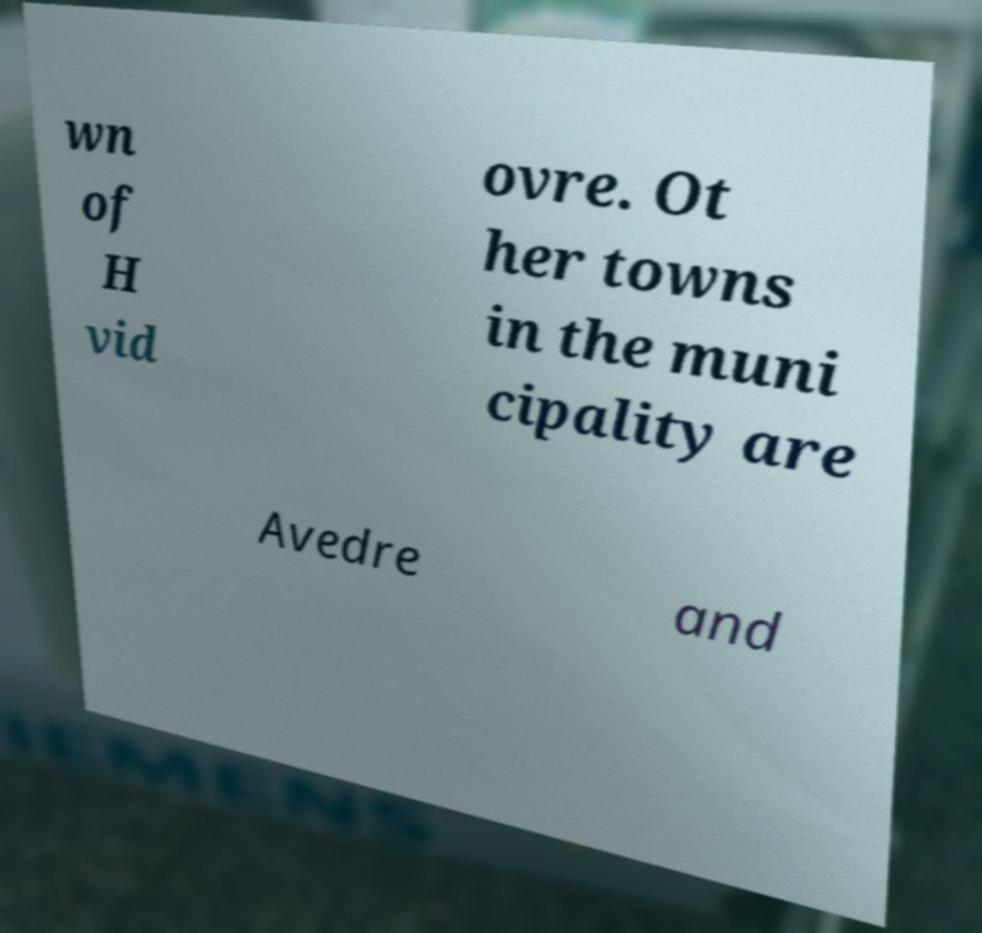Please identify and transcribe the text found in this image. wn of H vid ovre. Ot her towns in the muni cipality are Avedre and 